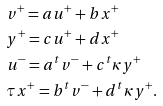Convert formula to latex. <formula><loc_0><loc_0><loc_500><loc_500>& v ^ { + } = a u ^ { + } + b x ^ { + } \\ & y ^ { + } = c u ^ { + } + d x ^ { + } \\ & u ^ { - } = a ^ { t } v ^ { - } + c ^ { t } \kappa y ^ { + } \\ & \tau x ^ { + } = b ^ { t } v ^ { - } + d ^ { t } \kappa y ^ { + } .</formula> 